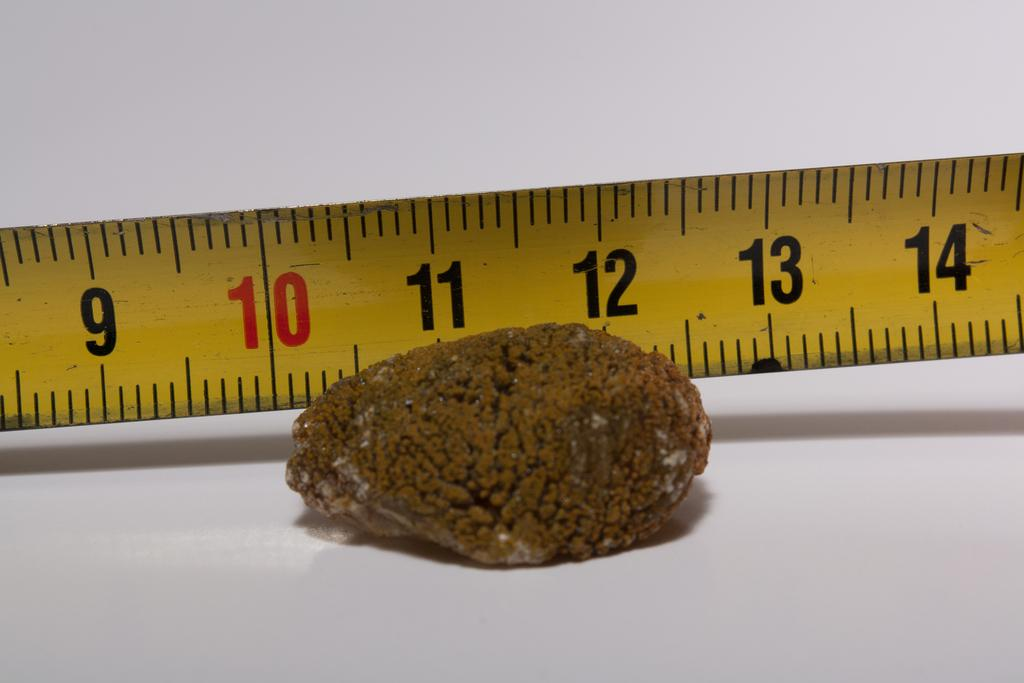Provide a one-sentence caption for the provided image. An brown object laying in front of a measuring tape that shows it measuring 2 inches. 